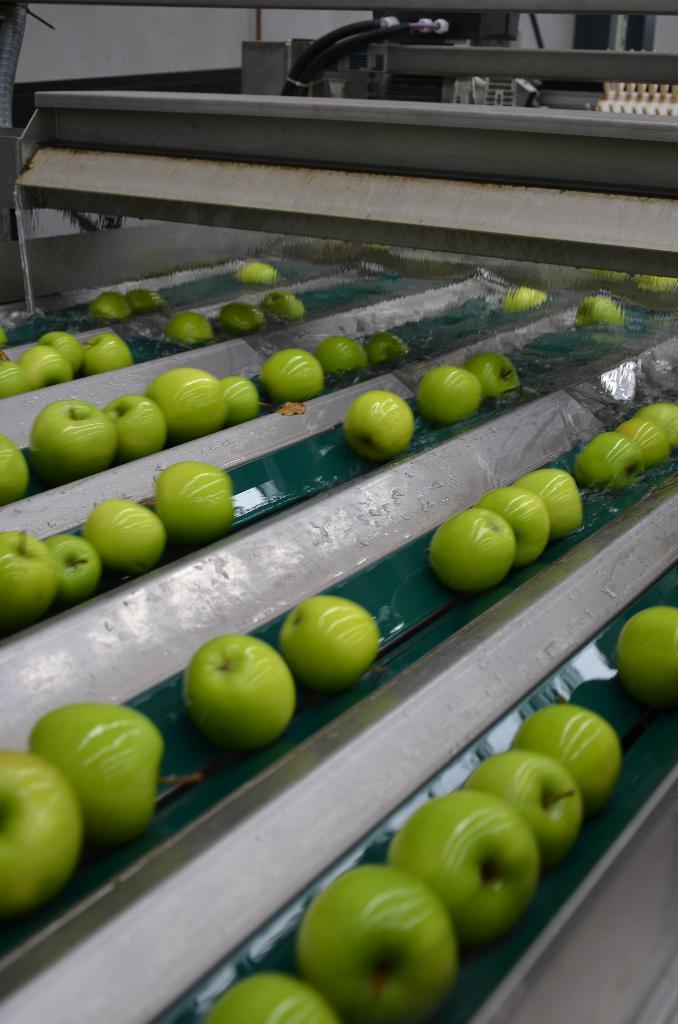Can you describe this image briefly? In this picture I can see green color fruits on some metal objects. In the background I can see machines. 